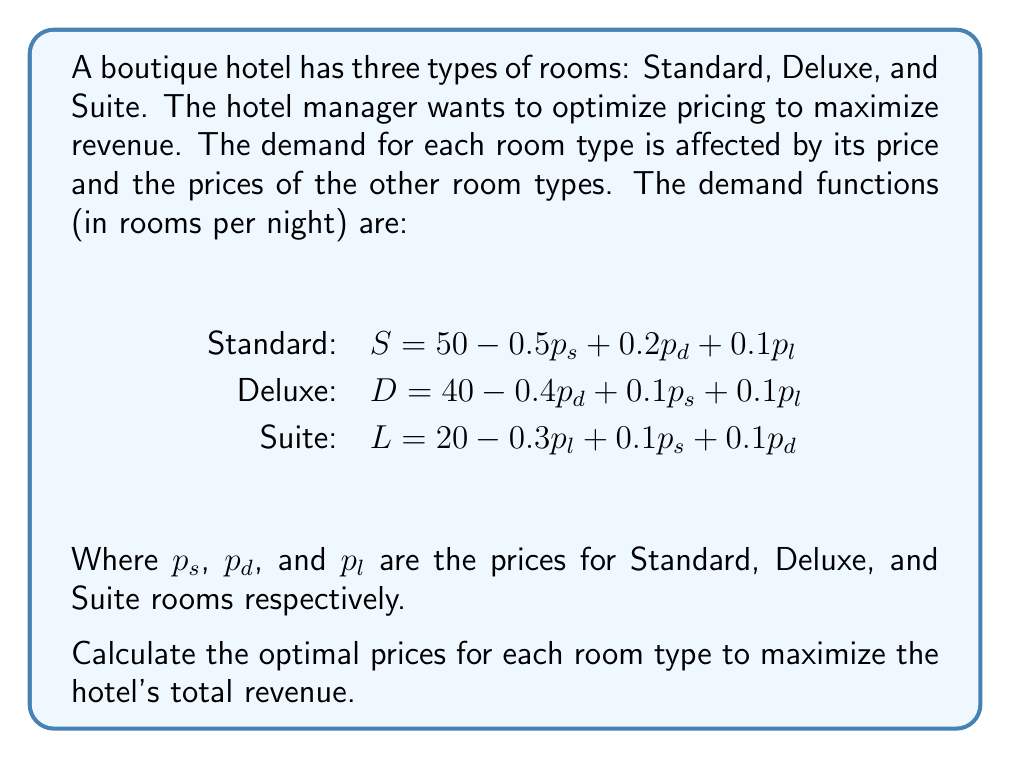Can you answer this question? To solve this problem, we need to follow these steps:

1) First, let's write the revenue function. The total revenue is the sum of revenues from each room type:

   $$R = p_sS + p_dD + p_lL$$

2) Substitute the demand functions into the revenue equation:

   $$R = p_s(50 - 0.5p_s + 0.2p_d + 0.1p_l) + p_d(40 - 0.4p_d + 0.1p_s + 0.1p_l) + p_l(20 - 0.3p_l + 0.1p_s + 0.1p_d)$$

3) Expand this equation:

   $$R = 50p_s - 0.5p_s^2 + 0.2p_sp_d + 0.1p_sp_l + 40p_d - 0.4p_d^2 + 0.1p_sp_d + 0.1p_dp_l + 20p_l - 0.3p_l^2 + 0.1p_sp_l + 0.1p_dp_l$$

4) To maximize revenue, we need to find where the partial derivatives with respect to each price are zero:

   $$\frac{\partial R}{\partial p_s} = 50 - p_s + 0.2p_d + 0.1p_l + 0.1p_d + 0.1p_l = 0$$
   $$\frac{\partial R}{\partial p_d} = 0.2p_s + 40 - 0.8p_d + 0.1p_l + 0.1p_s + 0.1p_l = 0$$
   $$\frac{\partial R}{\partial p_l} = 0.1p_s + 0.1p_d + 20 - 0.6p_l + 0.1p_s + 0.1p_d = 0$$

5) Simplify these equations:

   $$50 - p_s + 0.3p_d + 0.2p_l = 0$$
   $$0.3p_s + 40 - 0.8p_d + 0.2p_l = 0$$
   $$0.2p_s + 0.2p_d + 20 - 0.6p_l = 0$$

6) Solve this system of equations. We can use matrix methods or substitution. Using a computer algebra system, we get:

   $$p_s = 78.95$$
   $$p_d = 89.47$$
   $$p_l = 94.74$$

7) Round to the nearest whole number for practical pricing:

   $$p_s = 79$$
   $$p_d = 89$$
   $$p_l = 95$$
Answer: The optimal prices to maximize revenue are:
Standard room: $79
Deluxe room: $89
Suite: $95 